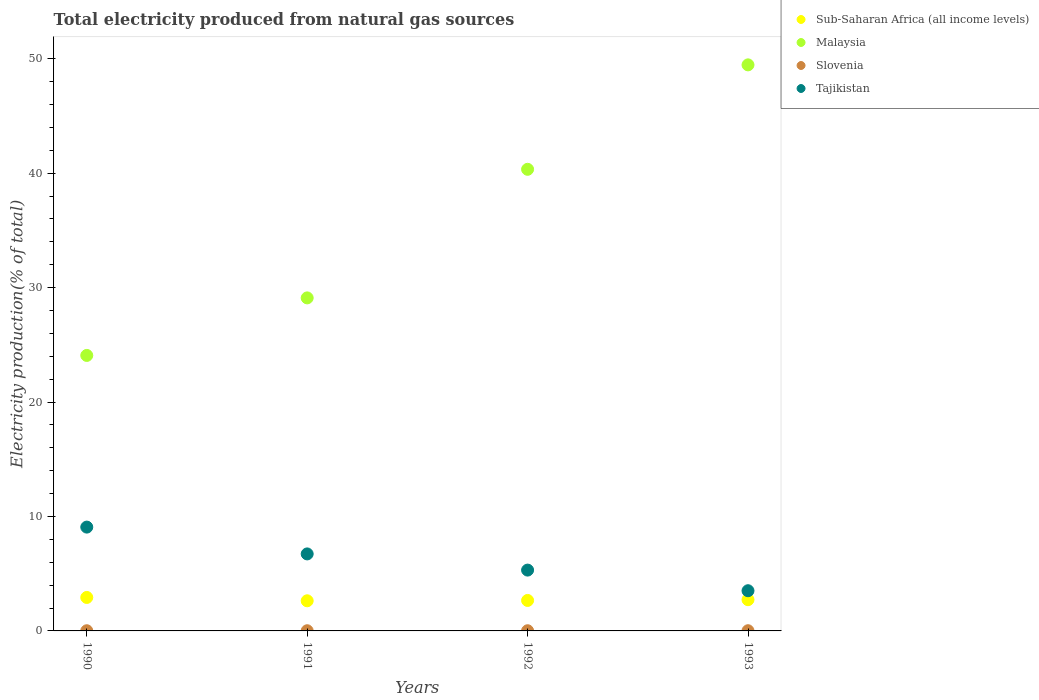How many different coloured dotlines are there?
Provide a short and direct response. 4. What is the total electricity produced in Tajikistan in 1990?
Your response must be concise. 9.07. Across all years, what is the maximum total electricity produced in Sub-Saharan Africa (all income levels)?
Your answer should be compact. 2.92. Across all years, what is the minimum total electricity produced in Tajikistan?
Provide a succinct answer. 3.51. What is the total total electricity produced in Tajikistan in the graph?
Provide a succinct answer. 24.63. What is the difference between the total electricity produced in Slovenia in 1990 and that in 1992?
Keep it short and to the point. -0. What is the difference between the total electricity produced in Malaysia in 1993 and the total electricity produced in Slovenia in 1991?
Your answer should be compact. 49.44. What is the average total electricity produced in Sub-Saharan Africa (all income levels) per year?
Your response must be concise. 2.74. In the year 1992, what is the difference between the total electricity produced in Sub-Saharan Africa (all income levels) and total electricity produced in Slovenia?
Keep it short and to the point. 2.65. What is the ratio of the total electricity produced in Slovenia in 1991 to that in 1992?
Your response must be concise. 0.97. What is the difference between the highest and the second highest total electricity produced in Sub-Saharan Africa (all income levels)?
Provide a short and direct response. 0.2. What is the difference between the highest and the lowest total electricity produced in Sub-Saharan Africa (all income levels)?
Provide a short and direct response. 0.29. In how many years, is the total electricity produced in Slovenia greater than the average total electricity produced in Slovenia taken over all years?
Your answer should be very brief. 2. Is it the case that in every year, the sum of the total electricity produced in Malaysia and total electricity produced in Sub-Saharan Africa (all income levels)  is greater than the sum of total electricity produced in Slovenia and total electricity produced in Tajikistan?
Your answer should be very brief. Yes. Does the total electricity produced in Malaysia monotonically increase over the years?
Offer a terse response. Yes. Is the total electricity produced in Malaysia strictly greater than the total electricity produced in Sub-Saharan Africa (all income levels) over the years?
Keep it short and to the point. Yes. How many dotlines are there?
Offer a very short reply. 4. How many years are there in the graph?
Provide a succinct answer. 4. What is the difference between two consecutive major ticks on the Y-axis?
Provide a succinct answer. 10. Where does the legend appear in the graph?
Offer a very short reply. Top right. How are the legend labels stacked?
Your response must be concise. Vertical. What is the title of the graph?
Give a very brief answer. Total electricity produced from natural gas sources. Does "Maldives" appear as one of the legend labels in the graph?
Ensure brevity in your answer.  No. What is the Electricity production(% of total) in Sub-Saharan Africa (all income levels) in 1990?
Make the answer very short. 2.92. What is the Electricity production(% of total) in Malaysia in 1990?
Offer a very short reply. 24.07. What is the Electricity production(% of total) in Slovenia in 1990?
Provide a succinct answer. 0.02. What is the Electricity production(% of total) in Tajikistan in 1990?
Ensure brevity in your answer.  9.07. What is the Electricity production(% of total) of Sub-Saharan Africa (all income levels) in 1991?
Provide a short and direct response. 2.63. What is the Electricity production(% of total) in Malaysia in 1991?
Give a very brief answer. 29.1. What is the Electricity production(% of total) of Slovenia in 1991?
Your response must be concise. 0.02. What is the Electricity production(% of total) in Tajikistan in 1991?
Make the answer very short. 6.73. What is the Electricity production(% of total) in Sub-Saharan Africa (all income levels) in 1992?
Ensure brevity in your answer.  2.66. What is the Electricity production(% of total) in Malaysia in 1992?
Provide a short and direct response. 40.33. What is the Electricity production(% of total) of Slovenia in 1992?
Your response must be concise. 0.02. What is the Electricity production(% of total) in Tajikistan in 1992?
Offer a terse response. 5.31. What is the Electricity production(% of total) in Sub-Saharan Africa (all income levels) in 1993?
Your answer should be compact. 2.73. What is the Electricity production(% of total) in Malaysia in 1993?
Your response must be concise. 49.46. What is the Electricity production(% of total) in Slovenia in 1993?
Your response must be concise. 0.02. What is the Electricity production(% of total) of Tajikistan in 1993?
Keep it short and to the point. 3.51. Across all years, what is the maximum Electricity production(% of total) in Sub-Saharan Africa (all income levels)?
Your answer should be very brief. 2.92. Across all years, what is the maximum Electricity production(% of total) of Malaysia?
Ensure brevity in your answer.  49.46. Across all years, what is the maximum Electricity production(% of total) in Slovenia?
Give a very brief answer. 0.02. Across all years, what is the maximum Electricity production(% of total) in Tajikistan?
Your response must be concise. 9.07. Across all years, what is the minimum Electricity production(% of total) in Sub-Saharan Africa (all income levels)?
Your response must be concise. 2.63. Across all years, what is the minimum Electricity production(% of total) in Malaysia?
Give a very brief answer. 24.07. Across all years, what is the minimum Electricity production(% of total) in Slovenia?
Ensure brevity in your answer.  0.02. Across all years, what is the minimum Electricity production(% of total) in Tajikistan?
Make the answer very short. 3.51. What is the total Electricity production(% of total) of Sub-Saharan Africa (all income levels) in the graph?
Offer a terse response. 10.95. What is the total Electricity production(% of total) in Malaysia in the graph?
Offer a very short reply. 142.96. What is the total Electricity production(% of total) in Slovenia in the graph?
Provide a succinct answer. 0.06. What is the total Electricity production(% of total) of Tajikistan in the graph?
Make the answer very short. 24.63. What is the difference between the Electricity production(% of total) of Sub-Saharan Africa (all income levels) in 1990 and that in 1991?
Offer a terse response. 0.29. What is the difference between the Electricity production(% of total) in Malaysia in 1990 and that in 1991?
Offer a terse response. -5.03. What is the difference between the Electricity production(% of total) in Slovenia in 1990 and that in 1991?
Your answer should be very brief. 0. What is the difference between the Electricity production(% of total) of Tajikistan in 1990 and that in 1991?
Provide a short and direct response. 2.34. What is the difference between the Electricity production(% of total) of Sub-Saharan Africa (all income levels) in 1990 and that in 1992?
Keep it short and to the point. 0.26. What is the difference between the Electricity production(% of total) of Malaysia in 1990 and that in 1992?
Your response must be concise. -16.26. What is the difference between the Electricity production(% of total) in Slovenia in 1990 and that in 1992?
Make the answer very short. -0. What is the difference between the Electricity production(% of total) in Tajikistan in 1990 and that in 1992?
Provide a succinct answer. 3.76. What is the difference between the Electricity production(% of total) of Sub-Saharan Africa (all income levels) in 1990 and that in 1993?
Your response must be concise. 0.2. What is the difference between the Electricity production(% of total) in Malaysia in 1990 and that in 1993?
Give a very brief answer. -25.39. What is the difference between the Electricity production(% of total) of Slovenia in 1990 and that in 1993?
Provide a succinct answer. -0. What is the difference between the Electricity production(% of total) in Tajikistan in 1990 and that in 1993?
Give a very brief answer. 5.56. What is the difference between the Electricity production(% of total) of Sub-Saharan Africa (all income levels) in 1991 and that in 1992?
Provide a short and direct response. -0.03. What is the difference between the Electricity production(% of total) of Malaysia in 1991 and that in 1992?
Offer a terse response. -11.23. What is the difference between the Electricity production(% of total) of Slovenia in 1991 and that in 1992?
Offer a very short reply. -0. What is the difference between the Electricity production(% of total) of Tajikistan in 1991 and that in 1992?
Your answer should be compact. 1.41. What is the difference between the Electricity production(% of total) of Sub-Saharan Africa (all income levels) in 1991 and that in 1993?
Offer a very short reply. -0.1. What is the difference between the Electricity production(% of total) of Malaysia in 1991 and that in 1993?
Give a very brief answer. -20.36. What is the difference between the Electricity production(% of total) of Slovenia in 1991 and that in 1993?
Keep it short and to the point. -0. What is the difference between the Electricity production(% of total) of Tajikistan in 1991 and that in 1993?
Give a very brief answer. 3.22. What is the difference between the Electricity production(% of total) in Sub-Saharan Africa (all income levels) in 1992 and that in 1993?
Offer a terse response. -0.07. What is the difference between the Electricity production(% of total) of Malaysia in 1992 and that in 1993?
Your response must be concise. -9.13. What is the difference between the Electricity production(% of total) of Slovenia in 1992 and that in 1993?
Offer a terse response. -0. What is the difference between the Electricity production(% of total) of Tajikistan in 1992 and that in 1993?
Keep it short and to the point. 1.8. What is the difference between the Electricity production(% of total) of Sub-Saharan Africa (all income levels) in 1990 and the Electricity production(% of total) of Malaysia in 1991?
Your answer should be very brief. -26.17. What is the difference between the Electricity production(% of total) of Sub-Saharan Africa (all income levels) in 1990 and the Electricity production(% of total) of Slovenia in 1991?
Keep it short and to the point. 2.91. What is the difference between the Electricity production(% of total) of Sub-Saharan Africa (all income levels) in 1990 and the Electricity production(% of total) of Tajikistan in 1991?
Your response must be concise. -3.8. What is the difference between the Electricity production(% of total) of Malaysia in 1990 and the Electricity production(% of total) of Slovenia in 1991?
Offer a terse response. 24.05. What is the difference between the Electricity production(% of total) in Malaysia in 1990 and the Electricity production(% of total) in Tajikistan in 1991?
Offer a terse response. 17.34. What is the difference between the Electricity production(% of total) in Slovenia in 1990 and the Electricity production(% of total) in Tajikistan in 1991?
Your answer should be compact. -6.71. What is the difference between the Electricity production(% of total) in Sub-Saharan Africa (all income levels) in 1990 and the Electricity production(% of total) in Malaysia in 1992?
Provide a succinct answer. -37.41. What is the difference between the Electricity production(% of total) of Sub-Saharan Africa (all income levels) in 1990 and the Electricity production(% of total) of Slovenia in 1992?
Ensure brevity in your answer.  2.91. What is the difference between the Electricity production(% of total) in Sub-Saharan Africa (all income levels) in 1990 and the Electricity production(% of total) in Tajikistan in 1992?
Your answer should be compact. -2.39. What is the difference between the Electricity production(% of total) in Malaysia in 1990 and the Electricity production(% of total) in Slovenia in 1992?
Give a very brief answer. 24.05. What is the difference between the Electricity production(% of total) in Malaysia in 1990 and the Electricity production(% of total) in Tajikistan in 1992?
Give a very brief answer. 18.76. What is the difference between the Electricity production(% of total) of Slovenia in 1990 and the Electricity production(% of total) of Tajikistan in 1992?
Make the answer very short. -5.3. What is the difference between the Electricity production(% of total) of Sub-Saharan Africa (all income levels) in 1990 and the Electricity production(% of total) of Malaysia in 1993?
Your answer should be very brief. -46.53. What is the difference between the Electricity production(% of total) in Sub-Saharan Africa (all income levels) in 1990 and the Electricity production(% of total) in Slovenia in 1993?
Keep it short and to the point. 2.91. What is the difference between the Electricity production(% of total) in Sub-Saharan Africa (all income levels) in 1990 and the Electricity production(% of total) in Tajikistan in 1993?
Offer a very short reply. -0.59. What is the difference between the Electricity production(% of total) of Malaysia in 1990 and the Electricity production(% of total) of Slovenia in 1993?
Offer a very short reply. 24.05. What is the difference between the Electricity production(% of total) in Malaysia in 1990 and the Electricity production(% of total) in Tajikistan in 1993?
Ensure brevity in your answer.  20.56. What is the difference between the Electricity production(% of total) in Slovenia in 1990 and the Electricity production(% of total) in Tajikistan in 1993?
Your answer should be very brief. -3.5. What is the difference between the Electricity production(% of total) in Sub-Saharan Africa (all income levels) in 1991 and the Electricity production(% of total) in Malaysia in 1992?
Ensure brevity in your answer.  -37.7. What is the difference between the Electricity production(% of total) of Sub-Saharan Africa (all income levels) in 1991 and the Electricity production(% of total) of Slovenia in 1992?
Your answer should be compact. 2.62. What is the difference between the Electricity production(% of total) in Sub-Saharan Africa (all income levels) in 1991 and the Electricity production(% of total) in Tajikistan in 1992?
Provide a succinct answer. -2.68. What is the difference between the Electricity production(% of total) of Malaysia in 1991 and the Electricity production(% of total) of Slovenia in 1992?
Keep it short and to the point. 29.08. What is the difference between the Electricity production(% of total) of Malaysia in 1991 and the Electricity production(% of total) of Tajikistan in 1992?
Offer a very short reply. 23.78. What is the difference between the Electricity production(% of total) of Slovenia in 1991 and the Electricity production(% of total) of Tajikistan in 1992?
Ensure brevity in your answer.  -5.3. What is the difference between the Electricity production(% of total) of Sub-Saharan Africa (all income levels) in 1991 and the Electricity production(% of total) of Malaysia in 1993?
Make the answer very short. -46.82. What is the difference between the Electricity production(% of total) of Sub-Saharan Africa (all income levels) in 1991 and the Electricity production(% of total) of Slovenia in 1993?
Keep it short and to the point. 2.62. What is the difference between the Electricity production(% of total) of Sub-Saharan Africa (all income levels) in 1991 and the Electricity production(% of total) of Tajikistan in 1993?
Offer a terse response. -0.88. What is the difference between the Electricity production(% of total) of Malaysia in 1991 and the Electricity production(% of total) of Slovenia in 1993?
Give a very brief answer. 29.08. What is the difference between the Electricity production(% of total) in Malaysia in 1991 and the Electricity production(% of total) in Tajikistan in 1993?
Keep it short and to the point. 25.59. What is the difference between the Electricity production(% of total) in Slovenia in 1991 and the Electricity production(% of total) in Tajikistan in 1993?
Your response must be concise. -3.5. What is the difference between the Electricity production(% of total) in Sub-Saharan Africa (all income levels) in 1992 and the Electricity production(% of total) in Malaysia in 1993?
Your response must be concise. -46.79. What is the difference between the Electricity production(% of total) of Sub-Saharan Africa (all income levels) in 1992 and the Electricity production(% of total) of Slovenia in 1993?
Your response must be concise. 2.65. What is the difference between the Electricity production(% of total) of Sub-Saharan Africa (all income levels) in 1992 and the Electricity production(% of total) of Tajikistan in 1993?
Make the answer very short. -0.85. What is the difference between the Electricity production(% of total) in Malaysia in 1992 and the Electricity production(% of total) in Slovenia in 1993?
Give a very brief answer. 40.32. What is the difference between the Electricity production(% of total) of Malaysia in 1992 and the Electricity production(% of total) of Tajikistan in 1993?
Provide a succinct answer. 36.82. What is the difference between the Electricity production(% of total) of Slovenia in 1992 and the Electricity production(% of total) of Tajikistan in 1993?
Your response must be concise. -3.5. What is the average Electricity production(% of total) of Sub-Saharan Africa (all income levels) per year?
Your response must be concise. 2.74. What is the average Electricity production(% of total) of Malaysia per year?
Your answer should be compact. 35.74. What is the average Electricity production(% of total) of Slovenia per year?
Provide a short and direct response. 0.02. What is the average Electricity production(% of total) of Tajikistan per year?
Offer a very short reply. 6.16. In the year 1990, what is the difference between the Electricity production(% of total) in Sub-Saharan Africa (all income levels) and Electricity production(% of total) in Malaysia?
Your answer should be compact. -21.15. In the year 1990, what is the difference between the Electricity production(% of total) in Sub-Saharan Africa (all income levels) and Electricity production(% of total) in Slovenia?
Keep it short and to the point. 2.91. In the year 1990, what is the difference between the Electricity production(% of total) of Sub-Saharan Africa (all income levels) and Electricity production(% of total) of Tajikistan?
Offer a very short reply. -6.15. In the year 1990, what is the difference between the Electricity production(% of total) in Malaysia and Electricity production(% of total) in Slovenia?
Your answer should be compact. 24.05. In the year 1990, what is the difference between the Electricity production(% of total) of Malaysia and Electricity production(% of total) of Tajikistan?
Your answer should be compact. 15. In the year 1990, what is the difference between the Electricity production(% of total) in Slovenia and Electricity production(% of total) in Tajikistan?
Offer a terse response. -9.05. In the year 1991, what is the difference between the Electricity production(% of total) of Sub-Saharan Africa (all income levels) and Electricity production(% of total) of Malaysia?
Provide a short and direct response. -26.47. In the year 1991, what is the difference between the Electricity production(% of total) of Sub-Saharan Africa (all income levels) and Electricity production(% of total) of Slovenia?
Provide a short and direct response. 2.62. In the year 1991, what is the difference between the Electricity production(% of total) of Sub-Saharan Africa (all income levels) and Electricity production(% of total) of Tajikistan?
Provide a succinct answer. -4.1. In the year 1991, what is the difference between the Electricity production(% of total) in Malaysia and Electricity production(% of total) in Slovenia?
Provide a succinct answer. 29.08. In the year 1991, what is the difference between the Electricity production(% of total) of Malaysia and Electricity production(% of total) of Tajikistan?
Give a very brief answer. 22.37. In the year 1991, what is the difference between the Electricity production(% of total) of Slovenia and Electricity production(% of total) of Tajikistan?
Ensure brevity in your answer.  -6.71. In the year 1992, what is the difference between the Electricity production(% of total) of Sub-Saharan Africa (all income levels) and Electricity production(% of total) of Malaysia?
Offer a very short reply. -37.67. In the year 1992, what is the difference between the Electricity production(% of total) in Sub-Saharan Africa (all income levels) and Electricity production(% of total) in Slovenia?
Provide a short and direct response. 2.65. In the year 1992, what is the difference between the Electricity production(% of total) in Sub-Saharan Africa (all income levels) and Electricity production(% of total) in Tajikistan?
Your response must be concise. -2.65. In the year 1992, what is the difference between the Electricity production(% of total) in Malaysia and Electricity production(% of total) in Slovenia?
Your response must be concise. 40.32. In the year 1992, what is the difference between the Electricity production(% of total) of Malaysia and Electricity production(% of total) of Tajikistan?
Make the answer very short. 35.02. In the year 1992, what is the difference between the Electricity production(% of total) of Slovenia and Electricity production(% of total) of Tajikistan?
Provide a short and direct response. -5.3. In the year 1993, what is the difference between the Electricity production(% of total) of Sub-Saharan Africa (all income levels) and Electricity production(% of total) of Malaysia?
Ensure brevity in your answer.  -46.73. In the year 1993, what is the difference between the Electricity production(% of total) of Sub-Saharan Africa (all income levels) and Electricity production(% of total) of Slovenia?
Your answer should be compact. 2.71. In the year 1993, what is the difference between the Electricity production(% of total) in Sub-Saharan Africa (all income levels) and Electricity production(% of total) in Tajikistan?
Provide a succinct answer. -0.78. In the year 1993, what is the difference between the Electricity production(% of total) of Malaysia and Electricity production(% of total) of Slovenia?
Ensure brevity in your answer.  49.44. In the year 1993, what is the difference between the Electricity production(% of total) of Malaysia and Electricity production(% of total) of Tajikistan?
Your answer should be very brief. 45.95. In the year 1993, what is the difference between the Electricity production(% of total) of Slovenia and Electricity production(% of total) of Tajikistan?
Provide a succinct answer. -3.49. What is the ratio of the Electricity production(% of total) in Sub-Saharan Africa (all income levels) in 1990 to that in 1991?
Keep it short and to the point. 1.11. What is the ratio of the Electricity production(% of total) of Malaysia in 1990 to that in 1991?
Provide a short and direct response. 0.83. What is the ratio of the Electricity production(% of total) in Slovenia in 1990 to that in 1991?
Keep it short and to the point. 1.02. What is the ratio of the Electricity production(% of total) of Tajikistan in 1990 to that in 1991?
Keep it short and to the point. 1.35. What is the ratio of the Electricity production(% of total) of Sub-Saharan Africa (all income levels) in 1990 to that in 1992?
Give a very brief answer. 1.1. What is the ratio of the Electricity production(% of total) of Malaysia in 1990 to that in 1992?
Offer a very short reply. 0.6. What is the ratio of the Electricity production(% of total) of Slovenia in 1990 to that in 1992?
Ensure brevity in your answer.  0.99. What is the ratio of the Electricity production(% of total) of Tajikistan in 1990 to that in 1992?
Your response must be concise. 1.71. What is the ratio of the Electricity production(% of total) of Sub-Saharan Africa (all income levels) in 1990 to that in 1993?
Offer a terse response. 1.07. What is the ratio of the Electricity production(% of total) of Malaysia in 1990 to that in 1993?
Provide a short and direct response. 0.49. What is the ratio of the Electricity production(% of total) of Slovenia in 1990 to that in 1993?
Make the answer very short. 0.96. What is the ratio of the Electricity production(% of total) of Tajikistan in 1990 to that in 1993?
Your answer should be compact. 2.58. What is the ratio of the Electricity production(% of total) of Sub-Saharan Africa (all income levels) in 1991 to that in 1992?
Keep it short and to the point. 0.99. What is the ratio of the Electricity production(% of total) in Malaysia in 1991 to that in 1992?
Give a very brief answer. 0.72. What is the ratio of the Electricity production(% of total) of Slovenia in 1991 to that in 1992?
Your answer should be very brief. 0.97. What is the ratio of the Electricity production(% of total) of Tajikistan in 1991 to that in 1992?
Your response must be concise. 1.27. What is the ratio of the Electricity production(% of total) of Sub-Saharan Africa (all income levels) in 1991 to that in 1993?
Give a very brief answer. 0.96. What is the ratio of the Electricity production(% of total) in Malaysia in 1991 to that in 1993?
Offer a very short reply. 0.59. What is the ratio of the Electricity production(% of total) of Slovenia in 1991 to that in 1993?
Provide a short and direct response. 0.94. What is the ratio of the Electricity production(% of total) in Tajikistan in 1991 to that in 1993?
Provide a short and direct response. 1.92. What is the ratio of the Electricity production(% of total) of Sub-Saharan Africa (all income levels) in 1992 to that in 1993?
Offer a very short reply. 0.98. What is the ratio of the Electricity production(% of total) of Malaysia in 1992 to that in 1993?
Your answer should be compact. 0.82. What is the ratio of the Electricity production(% of total) of Slovenia in 1992 to that in 1993?
Offer a terse response. 0.97. What is the ratio of the Electricity production(% of total) in Tajikistan in 1992 to that in 1993?
Ensure brevity in your answer.  1.51. What is the difference between the highest and the second highest Electricity production(% of total) of Sub-Saharan Africa (all income levels)?
Provide a succinct answer. 0.2. What is the difference between the highest and the second highest Electricity production(% of total) in Malaysia?
Offer a terse response. 9.13. What is the difference between the highest and the second highest Electricity production(% of total) in Slovenia?
Your answer should be compact. 0. What is the difference between the highest and the second highest Electricity production(% of total) of Tajikistan?
Ensure brevity in your answer.  2.34. What is the difference between the highest and the lowest Electricity production(% of total) in Sub-Saharan Africa (all income levels)?
Offer a very short reply. 0.29. What is the difference between the highest and the lowest Electricity production(% of total) in Malaysia?
Give a very brief answer. 25.39. What is the difference between the highest and the lowest Electricity production(% of total) of Tajikistan?
Provide a succinct answer. 5.56. 